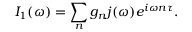Convert formula to latex. <formula><loc_0><loc_0><loc_500><loc_500>{ I _ { 1 } ( \omega ) = \sum _ { n } g _ { n } j ( \omega ) e ^ { i \omega n \tau } } .</formula> 